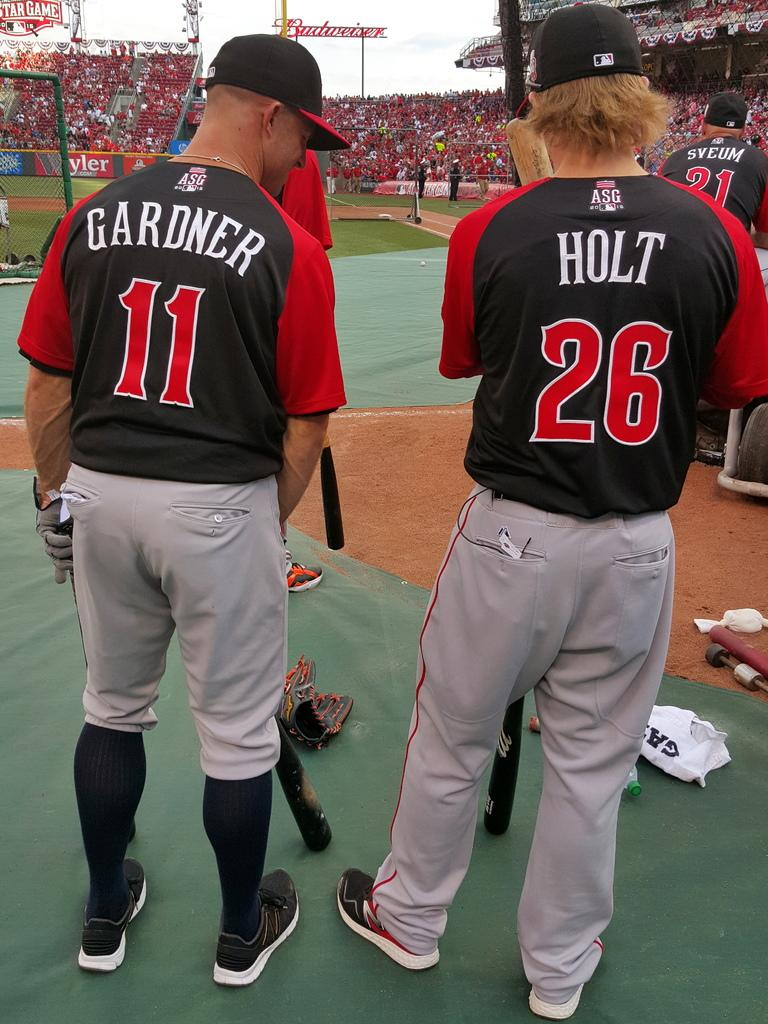<image>
Write a terse but informative summary of the picture. Two baseball players, one with Holt and one with Gardner on the back of their shirts. 